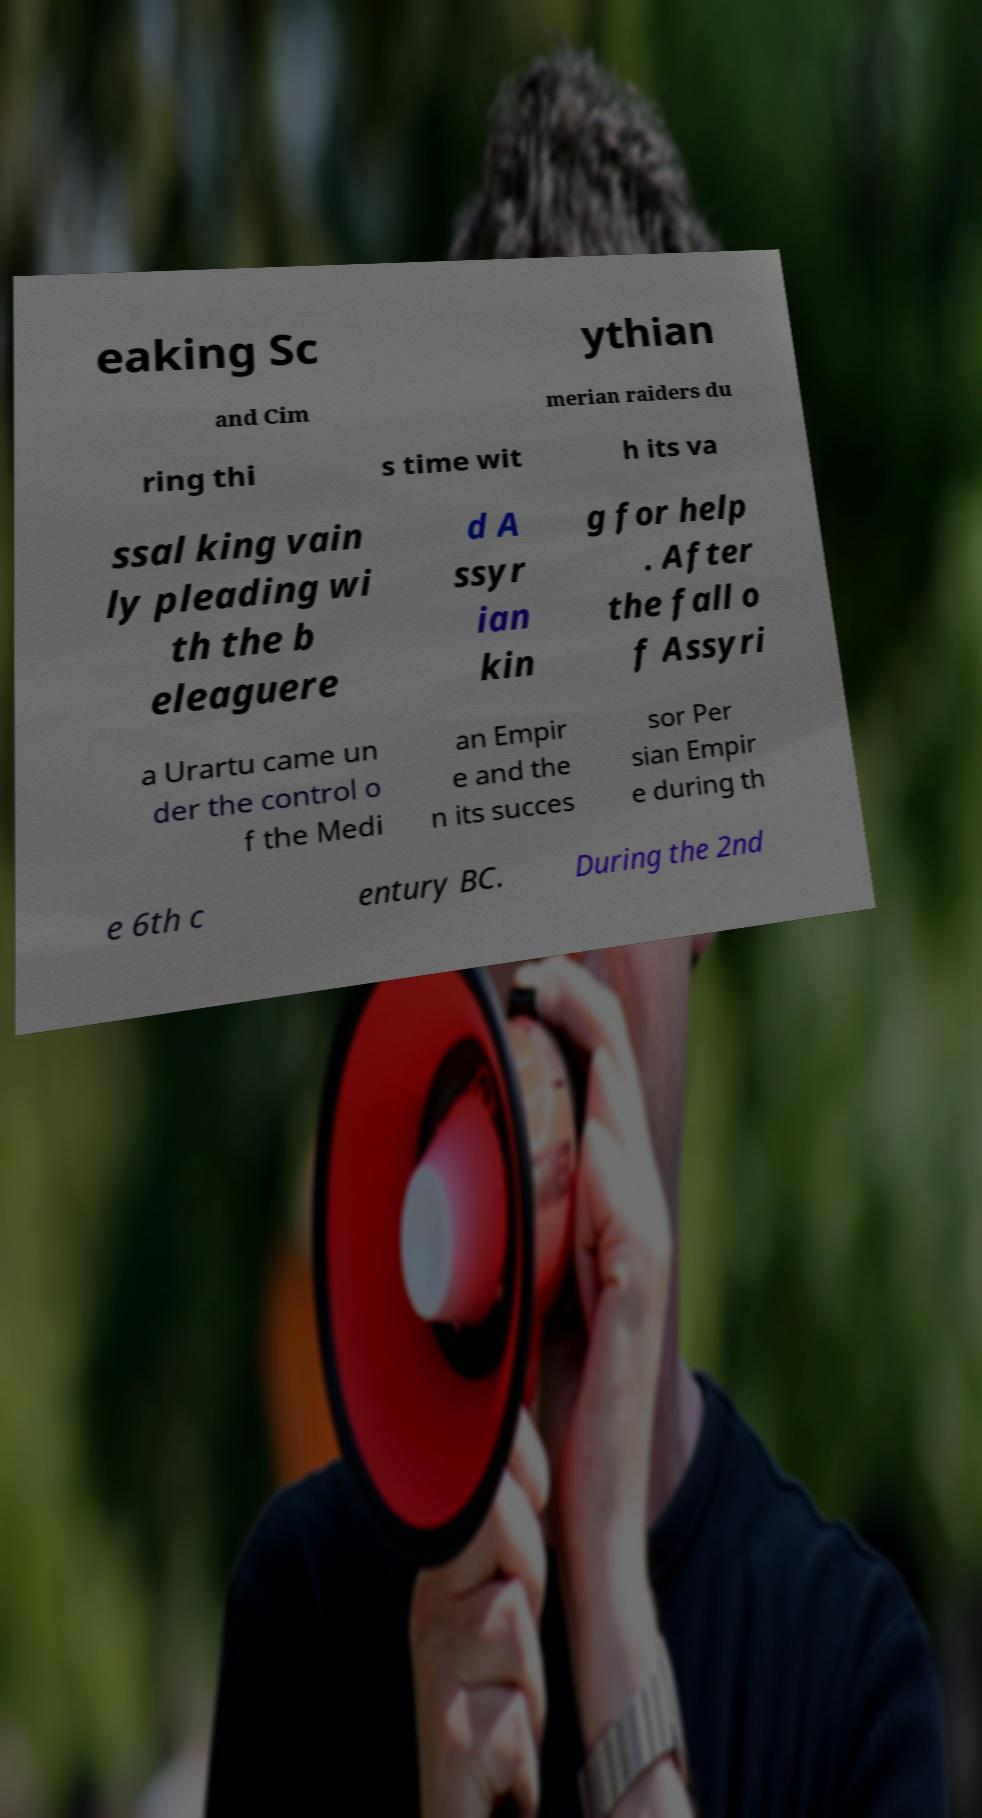Please read and relay the text visible in this image. What does it say? eaking Sc ythian and Cim merian raiders du ring thi s time wit h its va ssal king vain ly pleading wi th the b eleaguere d A ssyr ian kin g for help . After the fall o f Assyri a Urartu came un der the control o f the Medi an Empir e and the n its succes sor Per sian Empir e during th e 6th c entury BC. During the 2nd 